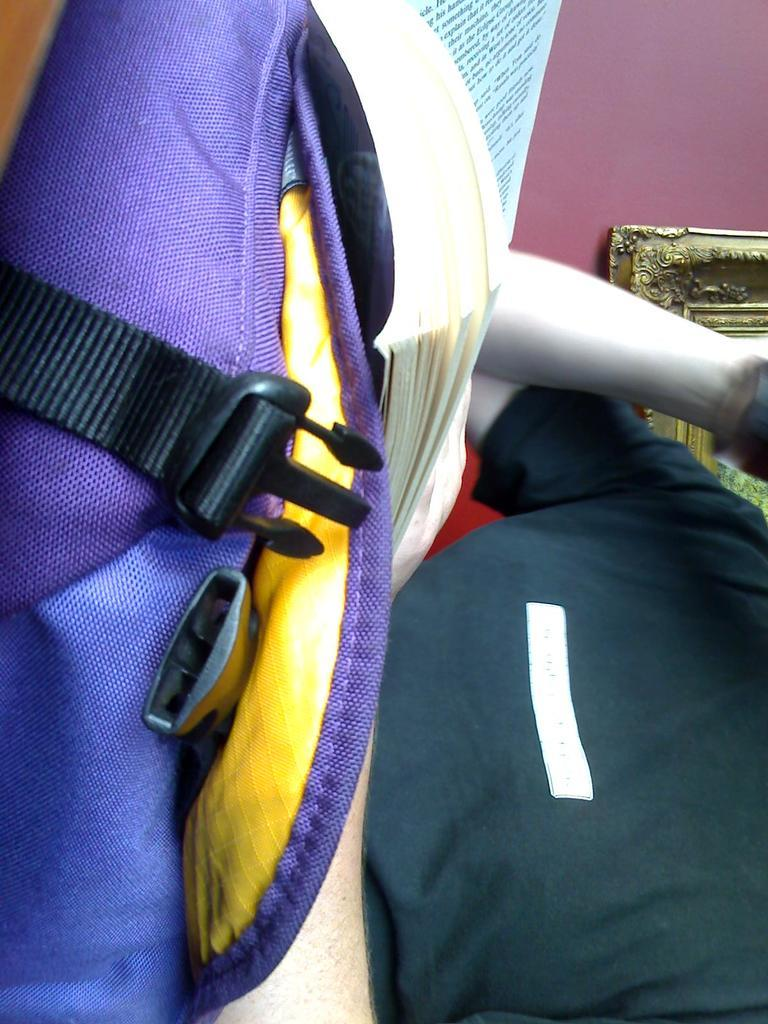What object is visible in the image that people often use to carry items? There is a bag in the image that people often use to carry items. What else can be seen in the image that people use for learning or entertainment? There is a book in the image that people use for learning or entertainment. Where are the bag and book located in the image? The bag and book are on a person in the image. What can be seen in the background of the image? There is a frame in the background of the image. How many soda cans are visible in the image? There are no soda cans visible in the image. Is there a nest in the frame in the background of the image? There is no nest present in the image, including the frame in the background. 